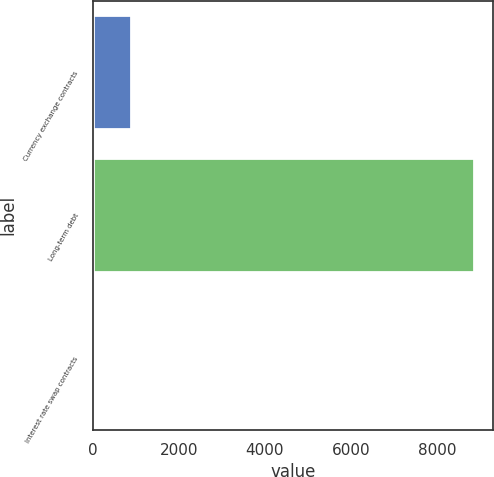Convert chart. <chart><loc_0><loc_0><loc_500><loc_500><bar_chart><fcel>Currency exchange contracts<fcel>Long-term debt<fcel>Interest rate swap contracts<nl><fcel>896.1<fcel>8862<fcel>11<nl></chart> 